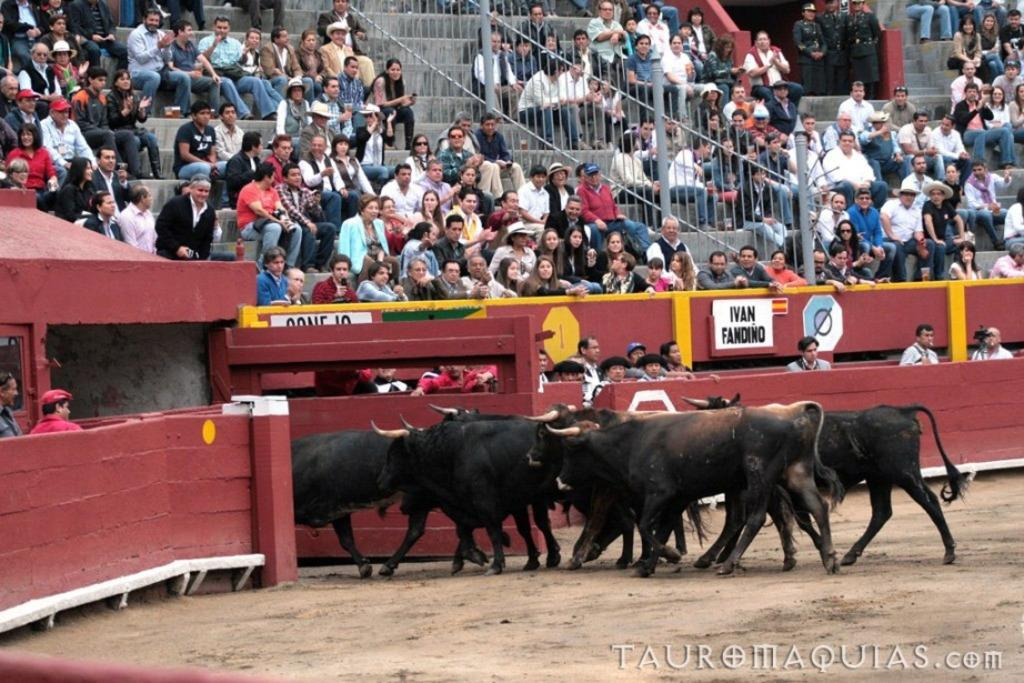What animals are on the ground in the image? There are bulls on the ground in the image. What are the people in the image doing? The people in the image are sitting on the steps. How many security guards are present in the image? There are three security guards standing in the image. What type of barrier is visible in the image? There is a wooden fence with a gate in the image. What type of suit is the skate wearing in the image? There is no skate or suit present in the image. What season is depicted in the image? The provided facts do not mention any seasonal details, so it cannot be determined from the image. 